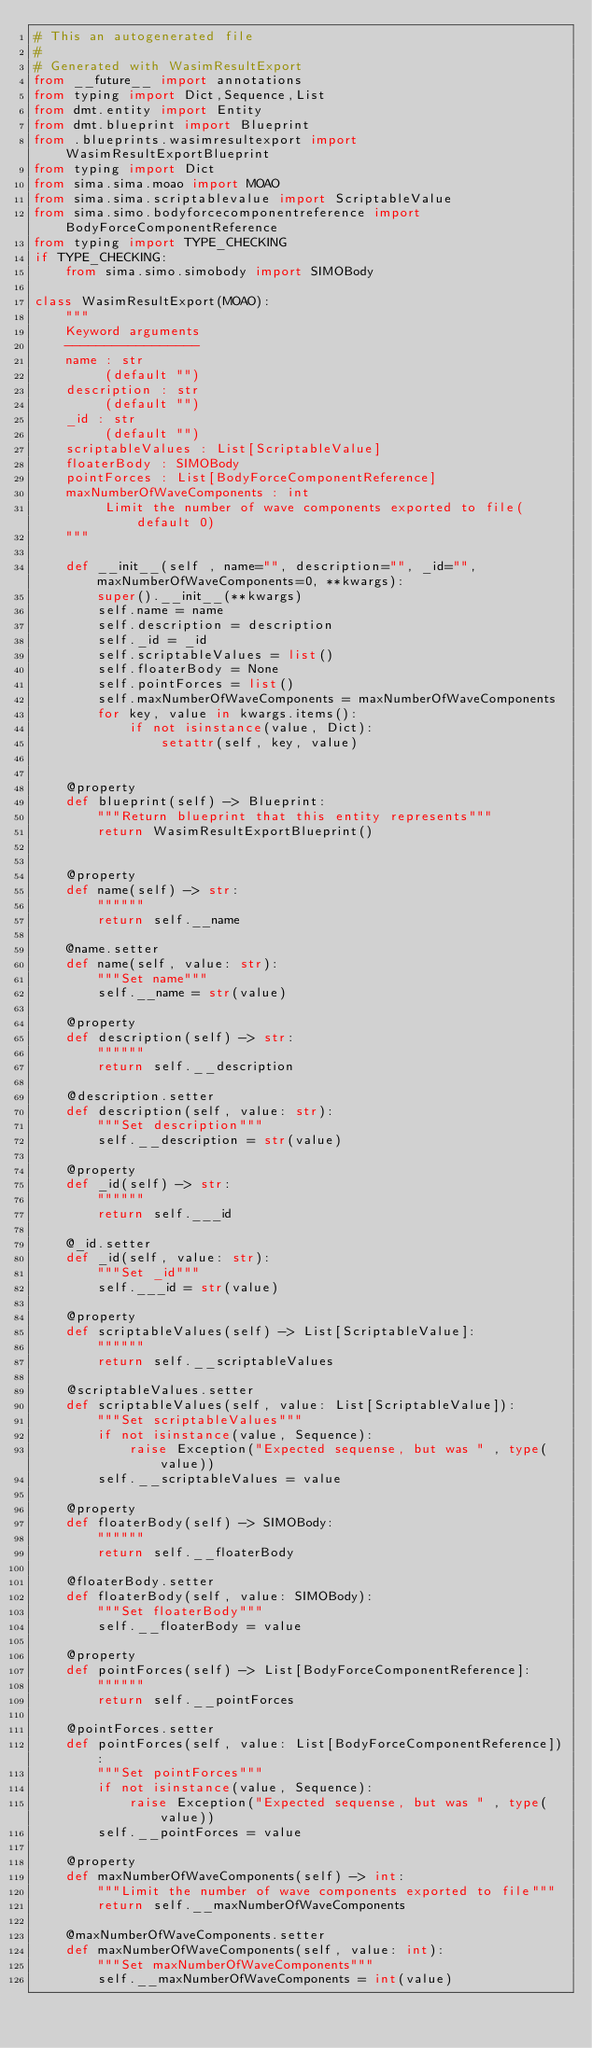Convert code to text. <code><loc_0><loc_0><loc_500><loc_500><_Python_># This an autogenerated file
# 
# Generated with WasimResultExport
from __future__ import annotations
from typing import Dict,Sequence,List
from dmt.entity import Entity
from dmt.blueprint import Blueprint
from .blueprints.wasimresultexport import WasimResultExportBlueprint
from typing import Dict
from sima.sima.moao import MOAO
from sima.sima.scriptablevalue import ScriptableValue
from sima.simo.bodyforcecomponentreference import BodyForceComponentReference
from typing import TYPE_CHECKING
if TYPE_CHECKING:
    from sima.simo.simobody import SIMOBody

class WasimResultExport(MOAO):
    """
    Keyword arguments
    -----------------
    name : str
         (default "")
    description : str
         (default "")
    _id : str
         (default "")
    scriptableValues : List[ScriptableValue]
    floaterBody : SIMOBody
    pointForces : List[BodyForceComponentReference]
    maxNumberOfWaveComponents : int
         Limit the number of wave components exported to file(default 0)
    """

    def __init__(self , name="", description="", _id="", maxNumberOfWaveComponents=0, **kwargs):
        super().__init__(**kwargs)
        self.name = name
        self.description = description
        self._id = _id
        self.scriptableValues = list()
        self.floaterBody = None
        self.pointForces = list()
        self.maxNumberOfWaveComponents = maxNumberOfWaveComponents
        for key, value in kwargs.items():
            if not isinstance(value, Dict):
                setattr(self, key, value)


    @property
    def blueprint(self) -> Blueprint:
        """Return blueprint that this entity represents"""
        return WasimResultExportBlueprint()


    @property
    def name(self) -> str:
        """"""
        return self.__name

    @name.setter
    def name(self, value: str):
        """Set name"""
        self.__name = str(value)

    @property
    def description(self) -> str:
        """"""
        return self.__description

    @description.setter
    def description(self, value: str):
        """Set description"""
        self.__description = str(value)

    @property
    def _id(self) -> str:
        """"""
        return self.___id

    @_id.setter
    def _id(self, value: str):
        """Set _id"""
        self.___id = str(value)

    @property
    def scriptableValues(self) -> List[ScriptableValue]:
        """"""
        return self.__scriptableValues

    @scriptableValues.setter
    def scriptableValues(self, value: List[ScriptableValue]):
        """Set scriptableValues"""
        if not isinstance(value, Sequence):
            raise Exception("Expected sequense, but was " , type(value))
        self.__scriptableValues = value

    @property
    def floaterBody(self) -> SIMOBody:
        """"""
        return self.__floaterBody

    @floaterBody.setter
    def floaterBody(self, value: SIMOBody):
        """Set floaterBody"""
        self.__floaterBody = value

    @property
    def pointForces(self) -> List[BodyForceComponentReference]:
        """"""
        return self.__pointForces

    @pointForces.setter
    def pointForces(self, value: List[BodyForceComponentReference]):
        """Set pointForces"""
        if not isinstance(value, Sequence):
            raise Exception("Expected sequense, but was " , type(value))
        self.__pointForces = value

    @property
    def maxNumberOfWaveComponents(self) -> int:
        """Limit the number of wave components exported to file"""
        return self.__maxNumberOfWaveComponents

    @maxNumberOfWaveComponents.setter
    def maxNumberOfWaveComponents(self, value: int):
        """Set maxNumberOfWaveComponents"""
        self.__maxNumberOfWaveComponents = int(value)
</code> 